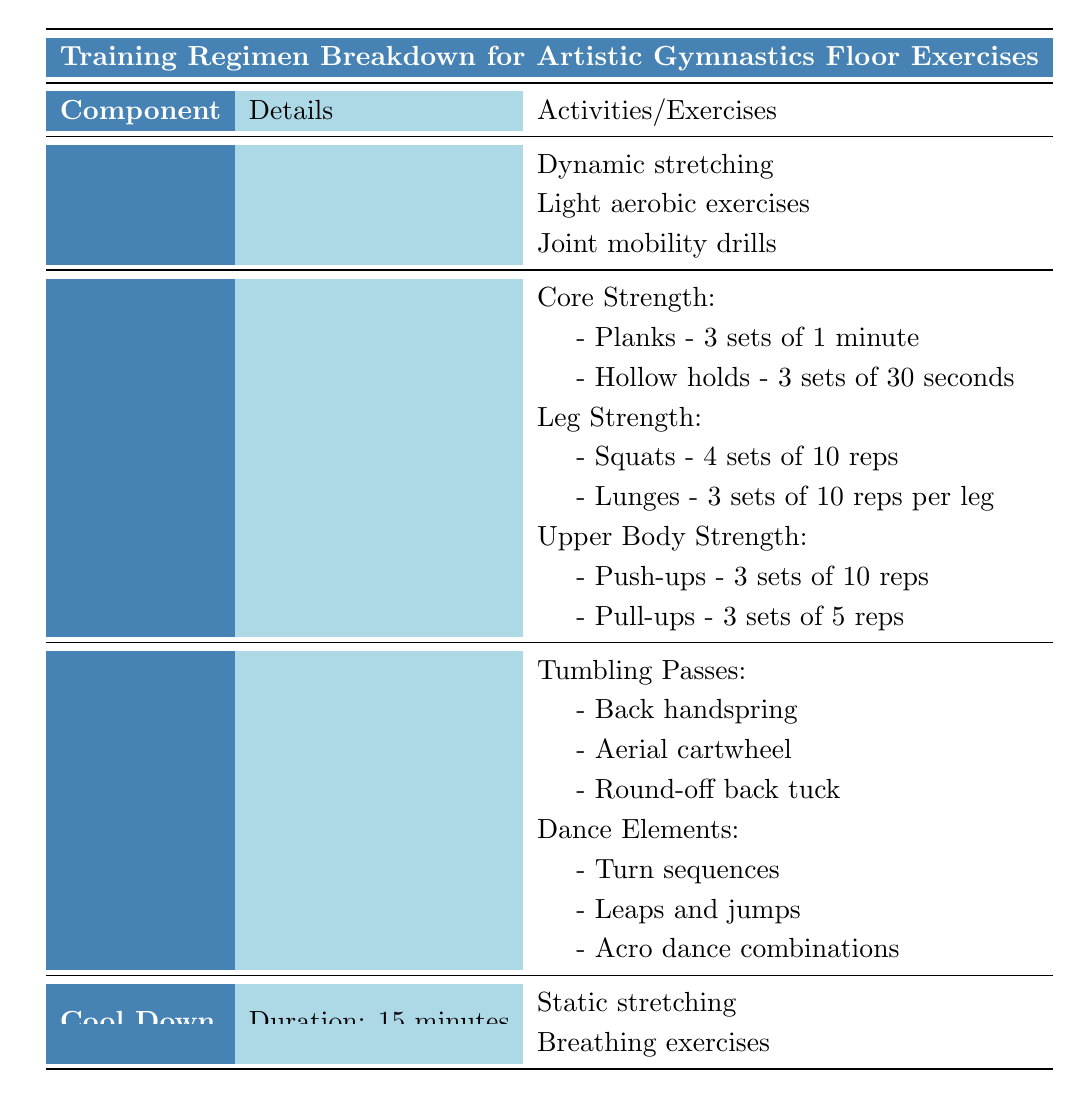What is the total duration of the entire training regimen? The training regimen consists of Warm Up (15 minutes), Strength Training (30 minutes), Skill Practice (45 minutes), and Cool Down (15 minutes). To find the total duration, we add these durations together: 15 + 30 + 45 + 15 = 105 minutes.
Answer: 105 minutes What exercises are included in the Core Strength training? The Core Strength training includes two exercises: Planks (3 sets of 1 minute) and Hollow holds (3 sets of 30 seconds). Both exercises are listed under the "Core Strength" section in the Strength Training component.
Answer: Planks and Hollow holds Is the duration of Skill Practice longer than Cool Down? The duration of Skill Practice is 45 minutes, while the duration of Cool Down is 15 minutes. Since 45 is greater than 15, the statement is true.
Answer: Yes How many total exercises are listed under Strength Training? There are three categories of exercises in Strength Training: Core Strength, Leg Strength, and Upper Body Strength. Each category contains its own exercises. Counting them, Core Strength has 2, Leg Strength has 2, and Upper Body Strength has 2, totaling 2 + 2 + 2 = 6 exercises.
Answer: 6 exercises What types of skills are practiced under Tumbling Passes? The Tumbling Passes section lists three types of skills: Back handspring, Aerial cartwheel, and Round-off back tuck. These are specified in the Skills Practice section.
Answer: Back handspring, Aerial cartwheel, Round-off back tuck Are breathing exercises included in the Warm Up activities? The Warm Up activities listed are Dynamic stretching, Light aerobic exercises, and Joint mobility drills. Breathing exercises are included only in the Cool Down activities. Therefore, the statement is false.
Answer: No What is the focus of the first activity listed in the Warm Up? The first activity listed under Warm Up is Dynamic stretching. The focus of this activity is to prepare the body through increasing flexibility and range of motion.
Answer: Dynamic stretching If a gymnast spends equal time on each exercise during Strength Training, how long would they spend on each exercise? Strength Training lasts for 30 minutes and includes 6 exercises (2 exercises each for Core, Leg, and Upper Body Strength). To find the time spent on each exercise, we divide the total time by the number of exercises: 30 minutes ÷ 6 exercises = 5 minutes per exercise.
Answer: 5 minutes per exercise 